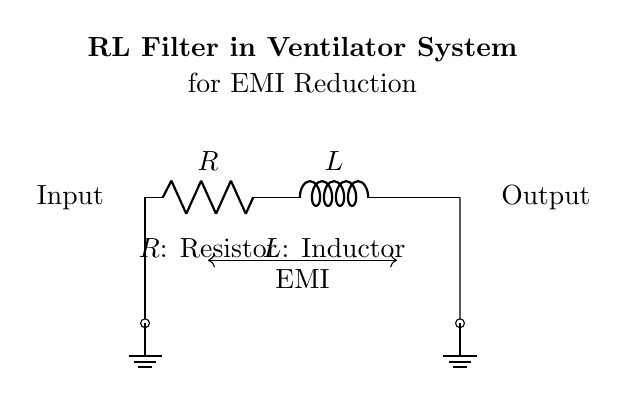What is the purpose of the resistor in this RL filter? The resistor in the RL filter is used to dissipate energy and limit the current flowing through the circuit. It helps in controlling the impedance seen by the load and increases the overall stability of the filter, aiding in electromagnetic interference reduction.
Answer: Dissipate energy What component is located between the resistor and the output? The component situated between the resistor and the output is an inductor. Inductors oppose changes in current, which is essential in filtering high-frequency noise caused by electromagnetic interference.
Answer: Inductor How does the arrangement of components in this circuit affect electromagnetic interference? The arrangement of the resistor and inductor creates an RL filter that attenuates high-frequency noise associated with electromagnetic interference. The resistor helps to stabilize the circuit, while the inductor limits unwanted current fluctuations, thus reducing EMI effects.
Answer: Attenuates high-frequency noise What is the direction of current flow indicated in the circuit? The current flow is indicated to be from left to right in the circuit, starting at the input, through the resistor and inductor, and then to the output. This is assumed based on conventional current flow principles.
Answer: Left to right What type of circuit is represented by the diagram? The circuit is a Resistor-Inductor (RL) filter circuit. This specific arrangement of components is used to filter signals by allowing low-frequency signals to pass while attenuating high-frequency signals, making it suitable for reducing noise in ventilator systems.
Answer: RL filter 